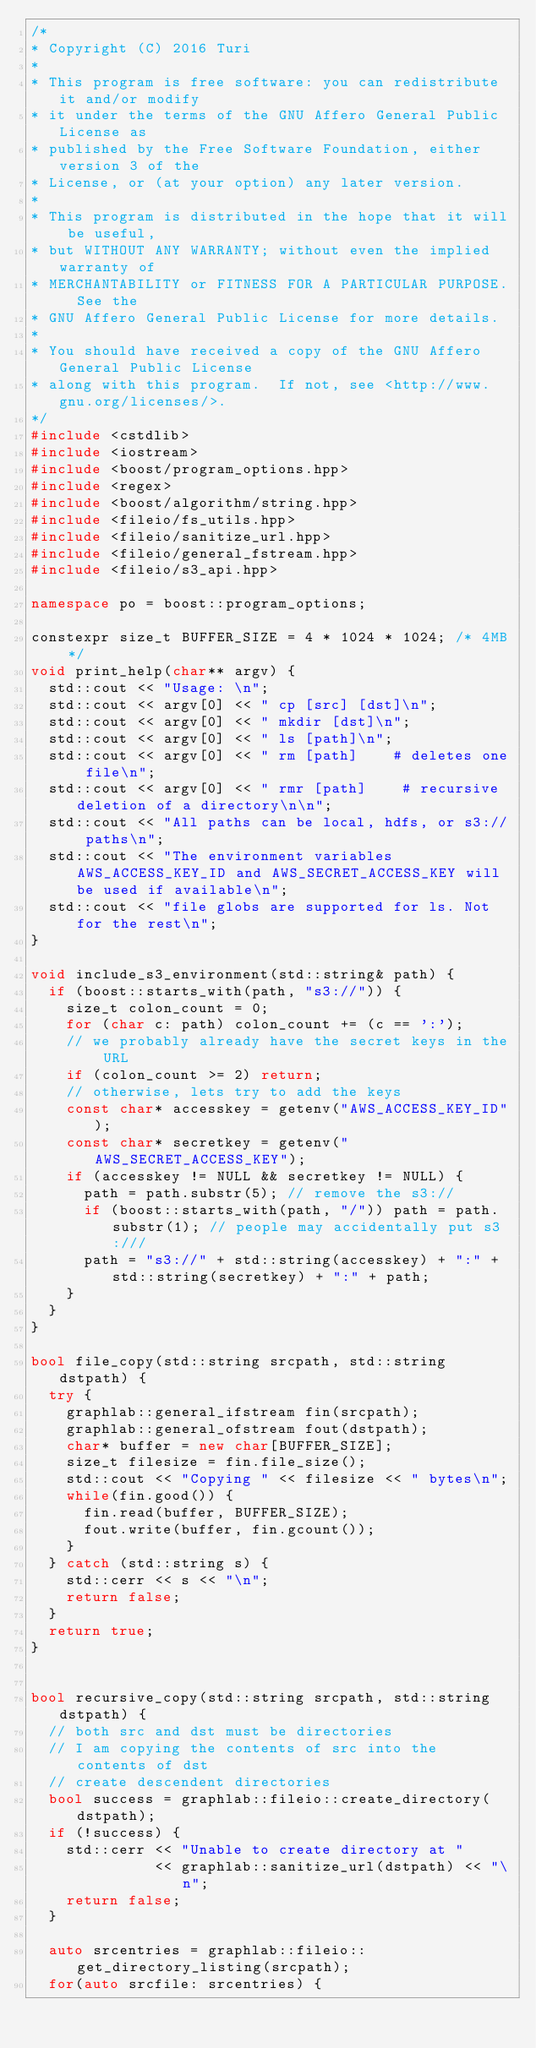<code> <loc_0><loc_0><loc_500><loc_500><_C++_>/*
* Copyright (C) 2016 Turi
*
* This program is free software: you can redistribute it and/or modify
* it under the terms of the GNU Affero General Public License as
* published by the Free Software Foundation, either version 3 of the
* License, or (at your option) any later version.
*
* This program is distributed in the hope that it will be useful,
* but WITHOUT ANY WARRANTY; without even the implied warranty of
* MERCHANTABILITY or FITNESS FOR A PARTICULAR PURPOSE.  See the
* GNU Affero General Public License for more details.
*
* You should have received a copy of the GNU Affero General Public License
* along with this program.  If not, see <http://www.gnu.org/licenses/>.
*/
#include <cstdlib>
#include <iostream>
#include <boost/program_options.hpp>
#include <regex>
#include <boost/algorithm/string.hpp>
#include <fileio/fs_utils.hpp>
#include <fileio/sanitize_url.hpp>
#include <fileio/general_fstream.hpp>
#include <fileio/s3_api.hpp>

namespace po = boost::program_options;      

constexpr size_t BUFFER_SIZE = 4 * 1024 * 1024; /* 4MB */
void print_help(char** argv) {
  std::cout << "Usage: \n";
  std::cout << argv[0] << " cp [src] [dst]\n";
  std::cout << argv[0] << " mkdir [dst]\n";
  std::cout << argv[0] << " ls [path]\n";
  std::cout << argv[0] << " rm [path]    # deletes one file\n";
  std::cout << argv[0] << " rmr [path]    # recursive deletion of a directory\n\n";
  std::cout << "All paths can be local, hdfs, or s3:// paths\n";
  std::cout << "The environment variables AWS_ACCESS_KEY_ID and AWS_SECRET_ACCESS_KEY will be used if available\n";
  std::cout << "file globs are supported for ls. Not for the rest\n";
}

void include_s3_environment(std::string& path) {
  if (boost::starts_with(path, "s3://")) {
    size_t colon_count = 0;
    for (char c: path) colon_count += (c == ':');
    // we probably already have the secret keys in the URL
    if (colon_count >= 2) return;
    // otherwise, lets try to add the keys
    const char* accesskey = getenv("AWS_ACCESS_KEY_ID");
    const char* secretkey = getenv("AWS_SECRET_ACCESS_KEY");
    if (accesskey != NULL && secretkey != NULL) {
      path = path.substr(5); // remove the s3://
      if (boost::starts_with(path, "/")) path = path.substr(1); // people may accidentally put s3:///
      path = "s3://" + std::string(accesskey) + ":" + std::string(secretkey) + ":" + path;
    }
  }
}

bool file_copy(std::string srcpath, std::string dstpath) {
  try {
    graphlab::general_ifstream fin(srcpath);
    graphlab::general_ofstream fout(dstpath);
    char* buffer = new char[BUFFER_SIZE];
    size_t filesize = fin.file_size();
    std::cout << "Copying " << filesize << " bytes\n";
    while(fin.good()) {
      fin.read(buffer, BUFFER_SIZE);
      fout.write(buffer, fin.gcount());
    }
  } catch (std::string s) {
    std::cerr << s << "\n";
    return false;
  }
  return true;
}


bool recursive_copy(std::string srcpath, std::string dstpath) {
  // both src and dst must be directories
  // I am copying the contents of src into the contents of dst
  // create descendent directories
  bool success = graphlab::fileio::create_directory(dstpath);
  if (!success) {
    std::cerr << "Unable to create directory at " 
              << graphlab::sanitize_url(dstpath) << "\n";
    return false;
  }

  auto srcentries = graphlab::fileio::get_directory_listing(srcpath);
  for(auto srcfile: srcentries) {</code> 